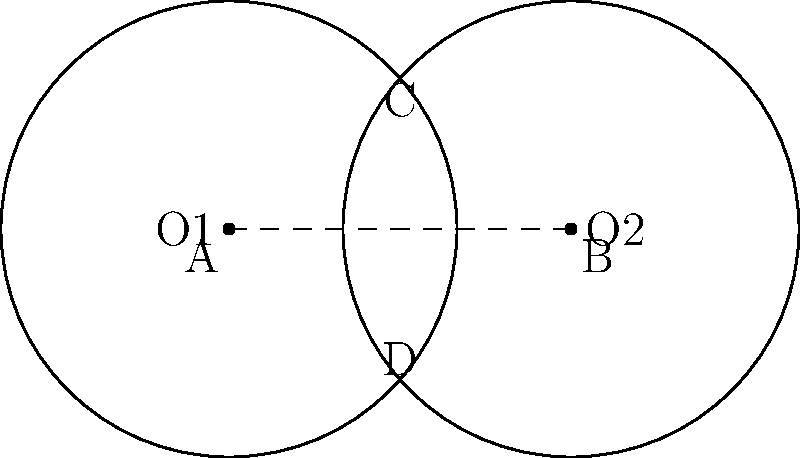In a curling match, two stones partially overlap on the ice. Each stone can be represented by a circle with a radius of 2 units. The centers of the stones are 3 units apart. Calculate the area of the overlapping region between the two stones. Round your answer to two decimal places. To find the area of overlap between two circles, we can follow these steps:

1) First, we need to find the central angle of the sector formed in each circle. Let's call this angle $\theta$.

   $\cos(\frac{\theta}{2}) = \frac{1.5}{2} = 0.75$
   $\theta = 2 \arccos(0.75) \approx 1.5708$ radians

2) The area of the sector in each circle is:
   $A_{sector} = \frac{1}{2}r^2\theta = \frac{1}{2} \cdot 2^2 \cdot 1.5708 \approx 3.1416$ square units

3) The area of the triangle formed by the centers of the circles and the intersection points is:
   $A_{triangle} = \frac{1}{2} \cdot 3 \cdot \sqrt{2^2 - 1.5^2} = \frac{3\sqrt{3}}{2} \approx 2.5981$ square units

4) The area of overlap is twice the difference between the sector area and the triangle area:
   $A_{overlap} = 2(A_{sector} - A_{triangle}) = 2(3.1416 - 2.5981) \approx 1.0870$ square units

5) Rounding to two decimal places: 1.09 square units
Answer: 1.09 square units 